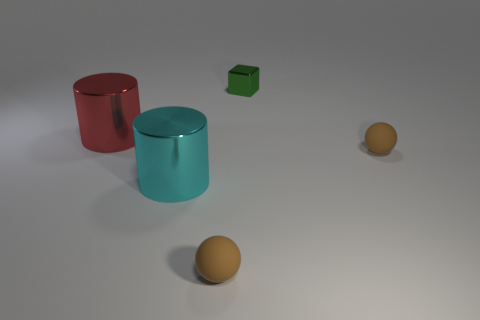Add 4 tiny green things. How many objects exist? 9 Subtract all balls. How many objects are left? 3 Subtract 0 green cylinders. How many objects are left? 5 Subtract all tiny purple matte things. Subtract all green things. How many objects are left? 4 Add 3 red metal objects. How many red metal objects are left? 4 Add 2 big gray cylinders. How many big gray cylinders exist? 2 